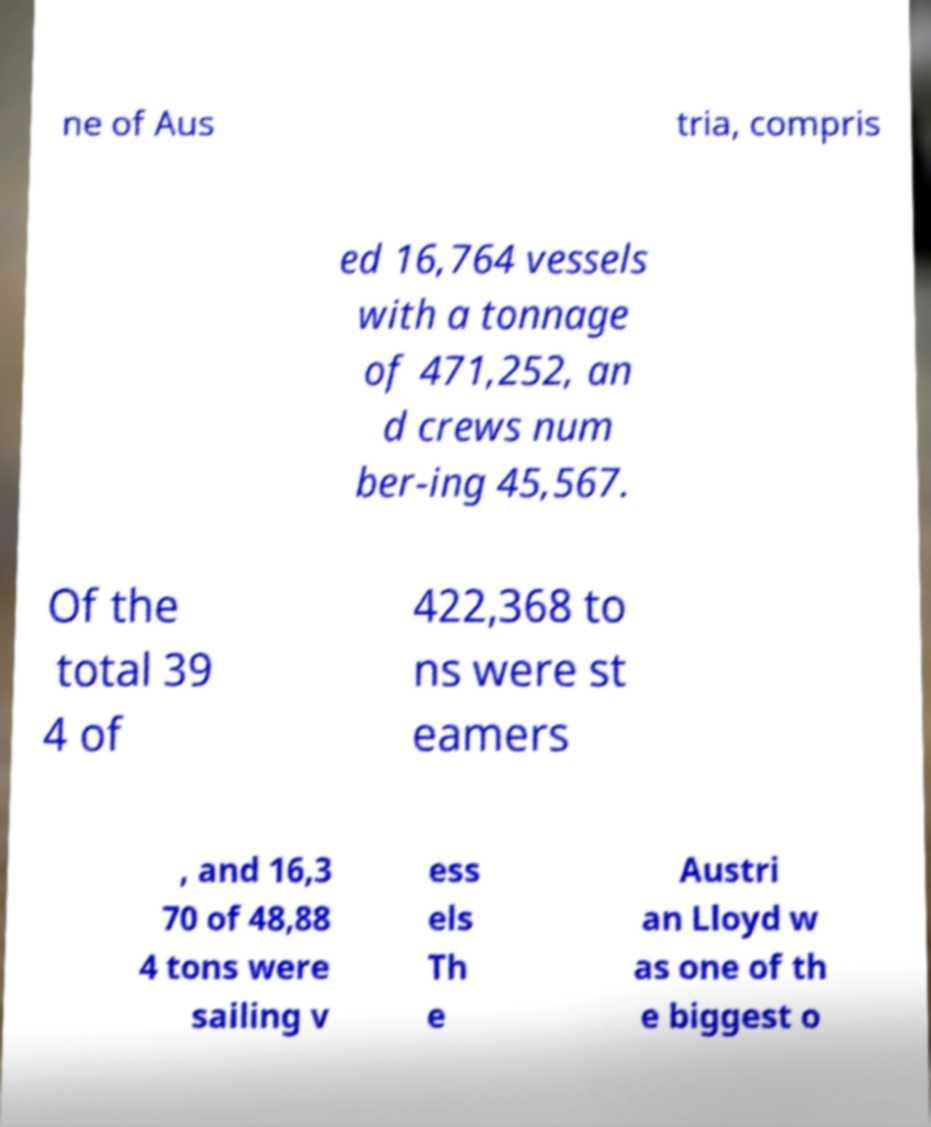Can you accurately transcribe the text from the provided image for me? ne of Aus tria, compris ed 16,764 vessels with a tonnage of 471,252, an d crews num ber-ing 45,567. Of the total 39 4 of 422,368 to ns were st eamers , and 16,3 70 of 48,88 4 tons were sailing v ess els Th e Austri an Lloyd w as one of th e biggest o 